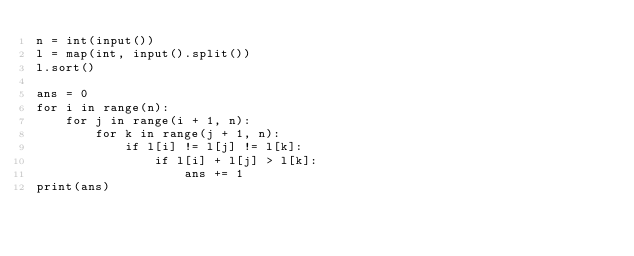Convert code to text. <code><loc_0><loc_0><loc_500><loc_500><_Python_>n = int(input())
l = map(int, input().split())
l.sort()

ans = 0
for i in range(n):
    for j in range(i + 1, n):
        for k in range(j + 1, n):
            if l[i] != l[j] != l[k]:
                if l[i] + l[j] > l[k]:
                    ans += 1
print(ans)</code> 